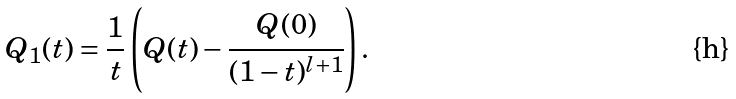Convert formula to latex. <formula><loc_0><loc_0><loc_500><loc_500>Q _ { 1 } ( t ) = \frac { 1 } { t } \left ( Q ( t ) - \cfrac { Q ( 0 ) } { ( 1 - t ) ^ { l + 1 } } \right ) .</formula> 